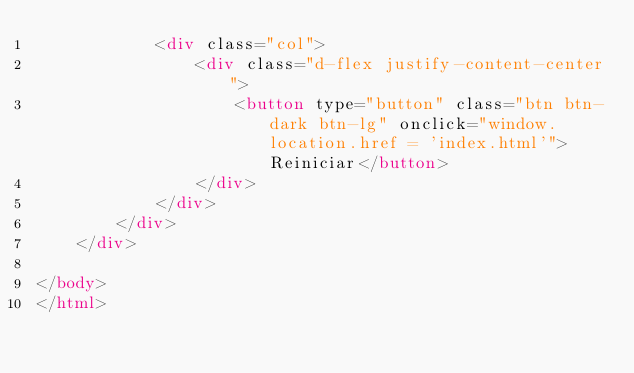<code> <loc_0><loc_0><loc_500><loc_500><_HTML_>            <div class="col">
                <div class="d-flex justify-content-center">
                    <button type="button" class="btn btn-dark btn-lg" onclick="window.location.href = 'index.html'">Reiniciar</button>
                </div>
            </div>
        </div>
    </div>

</body>
</html></code> 